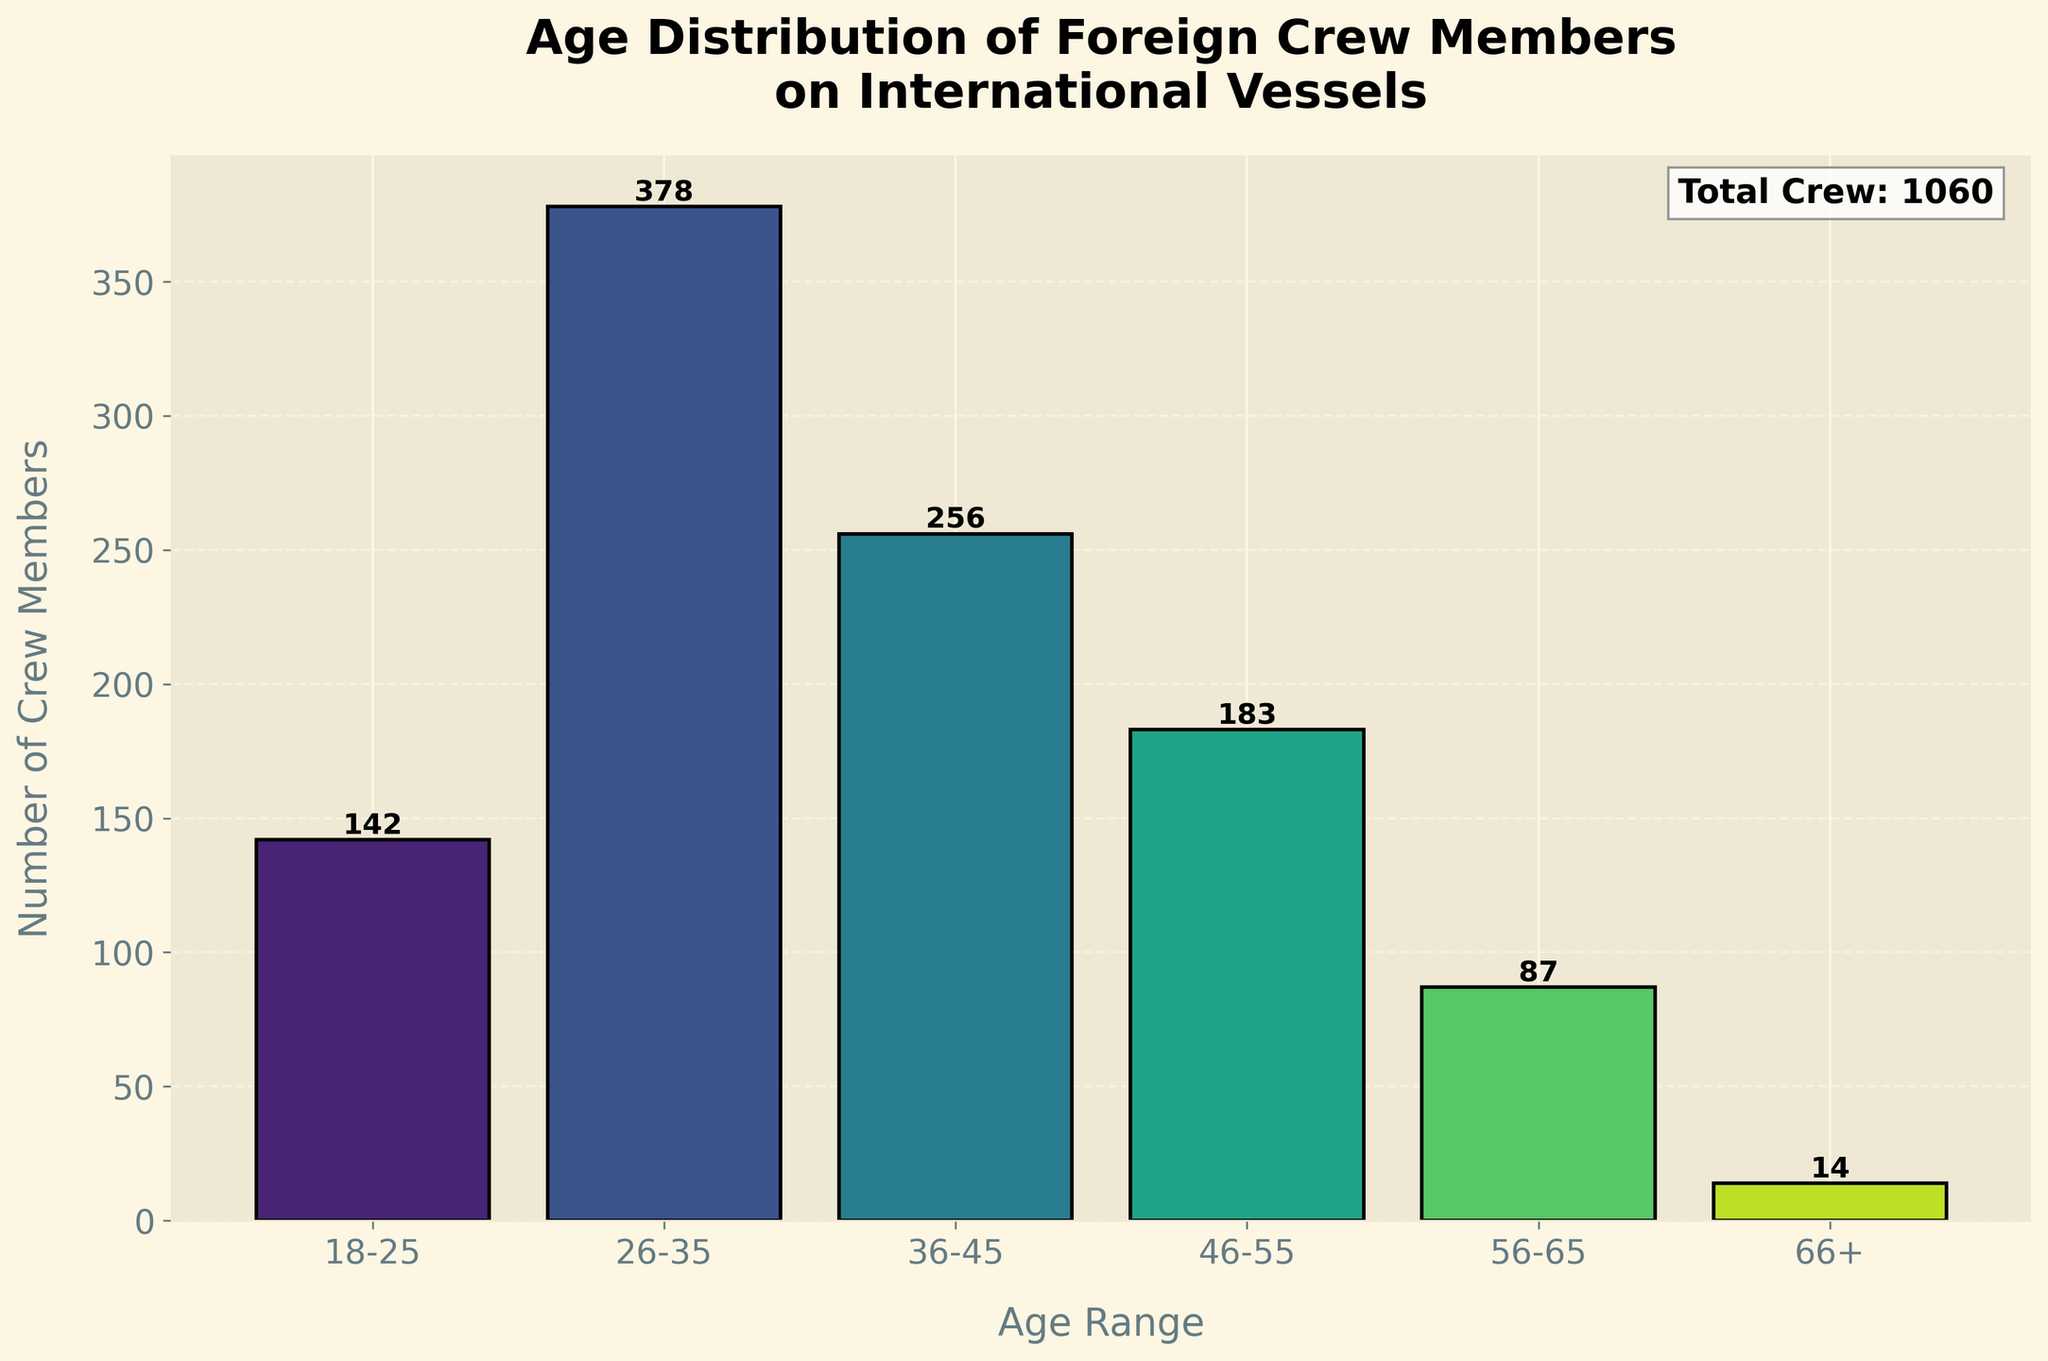What's the title of the figure? The title of the figure is displayed at the top and provides an overview of what the figure is about.
Answer: Age Distribution of Foreign Crew Members on International Vessels What is the age range with the highest number of crew members? Find the bar with the highest peak, then refer to the age range label at its base.
Answer: 26-35 How many crew members are in the 46-55 age range? Look at the bar corresponding to the 46-55 age range and check the number annotated on top of the bar.
Answer: 183 Which age range has the least number of crew members? Identify the shortest bar and refer to the age range label at its base.
Answer: 66+ What is the total number of crew members? Refer to the annotation at the top right corner of the plot, showing the sum of all crew members.
Answer: 1060 How many crew members are under 36 years old? Add the number of crew members in the 18-25 and 26-35 age ranges: 142 + 378.
Answer: 520 What is the difference in the number of crew members between the 36-45 and 56-65 age ranges? Subtract the number of crew members in the 56-65 age range from the 36-45 age range: 256 - 87.
Answer: 169 How many age ranges have more than 200 crew members? Count the number of bars with y-values greater than 200: 26-35 and 36-45.
Answer: 2 What percentage of the total crew members does the 26-35 age range constitute? Divide the number of crew members in the 26-35 age range by the total number of crew members and multiply by 100: (378 / 1060) * 100.
Answer: 35.66% Which age range has approximately half the number of the 26-35 age range? Find the age range whose crew member count is closest to half of the 26-35 range: 142 (18-25 is closest to half of 378).
Answer: 18-25 